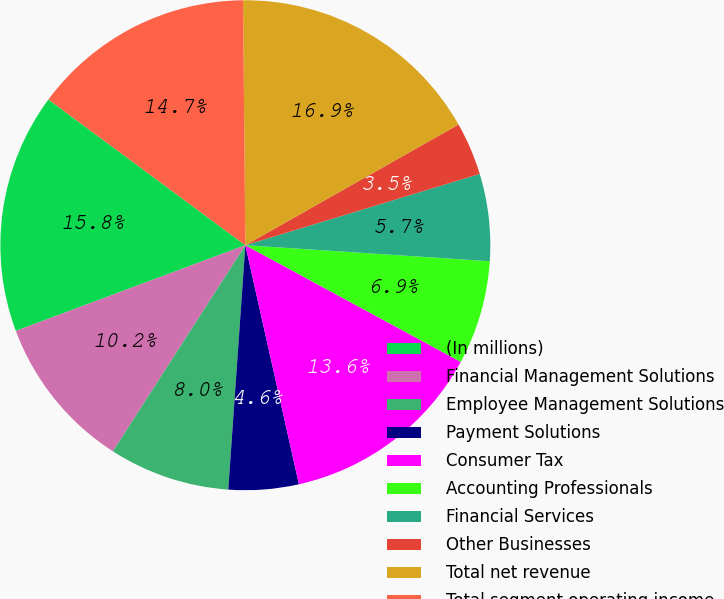<chart> <loc_0><loc_0><loc_500><loc_500><pie_chart><fcel>(In millions)<fcel>Financial Management Solutions<fcel>Employee Management Solutions<fcel>Payment Solutions<fcel>Consumer Tax<fcel>Accounting Professionals<fcel>Financial Services<fcel>Other Businesses<fcel>Total net revenue<fcel>Total segment operating income<nl><fcel>15.83%<fcel>10.22%<fcel>7.98%<fcel>4.62%<fcel>13.59%<fcel>6.86%<fcel>5.74%<fcel>3.5%<fcel>16.95%<fcel>14.71%<nl></chart> 